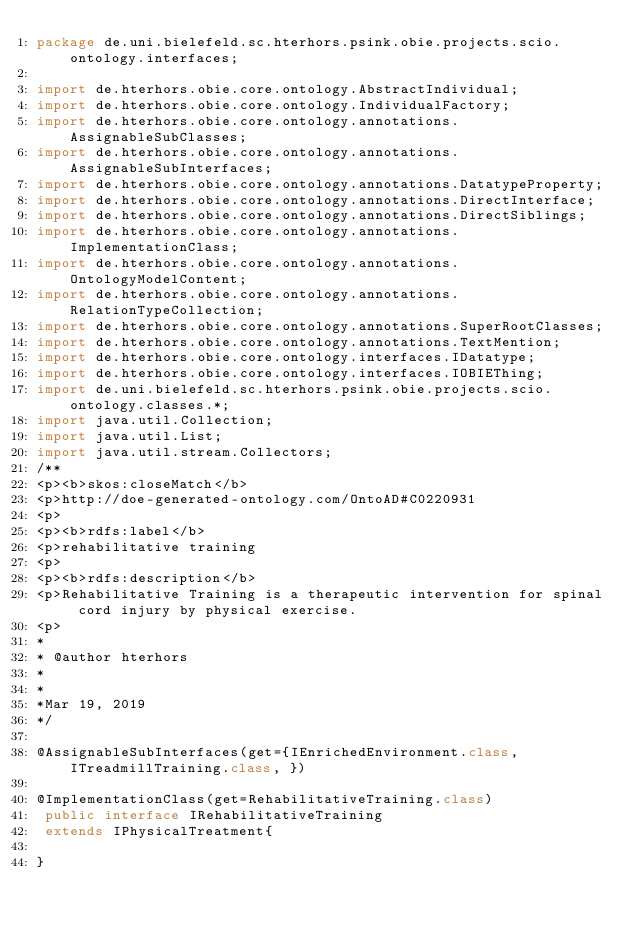Convert code to text. <code><loc_0><loc_0><loc_500><loc_500><_Java_>package de.uni.bielefeld.sc.hterhors.psink.obie.projects.scio.ontology.interfaces;

import de.hterhors.obie.core.ontology.AbstractIndividual;
import de.hterhors.obie.core.ontology.IndividualFactory;
import de.hterhors.obie.core.ontology.annotations.AssignableSubClasses;
import de.hterhors.obie.core.ontology.annotations.AssignableSubInterfaces;
import de.hterhors.obie.core.ontology.annotations.DatatypeProperty;
import de.hterhors.obie.core.ontology.annotations.DirectInterface;
import de.hterhors.obie.core.ontology.annotations.DirectSiblings;
import de.hterhors.obie.core.ontology.annotations.ImplementationClass;
import de.hterhors.obie.core.ontology.annotations.OntologyModelContent;
import de.hterhors.obie.core.ontology.annotations.RelationTypeCollection;
import de.hterhors.obie.core.ontology.annotations.SuperRootClasses;
import de.hterhors.obie.core.ontology.annotations.TextMention;
import de.hterhors.obie.core.ontology.interfaces.IDatatype;
import de.hterhors.obie.core.ontology.interfaces.IOBIEThing;
import de.uni.bielefeld.sc.hterhors.psink.obie.projects.scio.ontology.classes.*;
import java.util.Collection;
import java.util.List;
import java.util.stream.Collectors;
/**
<p><b>skos:closeMatch</b>
<p>http://doe-generated-ontology.com/OntoAD#C0220931
<p>
<p><b>rdfs:label</b>
<p>rehabilitative training
<p>
<p><b>rdfs:description</b>
<p>Rehabilitative Training is a therapeutic intervention for spinal cord injury by physical exercise.
<p>
*
* @author hterhors
*
*
*Mar 19, 2019
*/

@AssignableSubInterfaces(get={IEnrichedEnvironment.class, ITreadmillTraining.class, })

@ImplementationClass(get=RehabilitativeTraining.class)
 public interface IRehabilitativeTraining
 extends IPhysicalTreatment{

}
</code> 